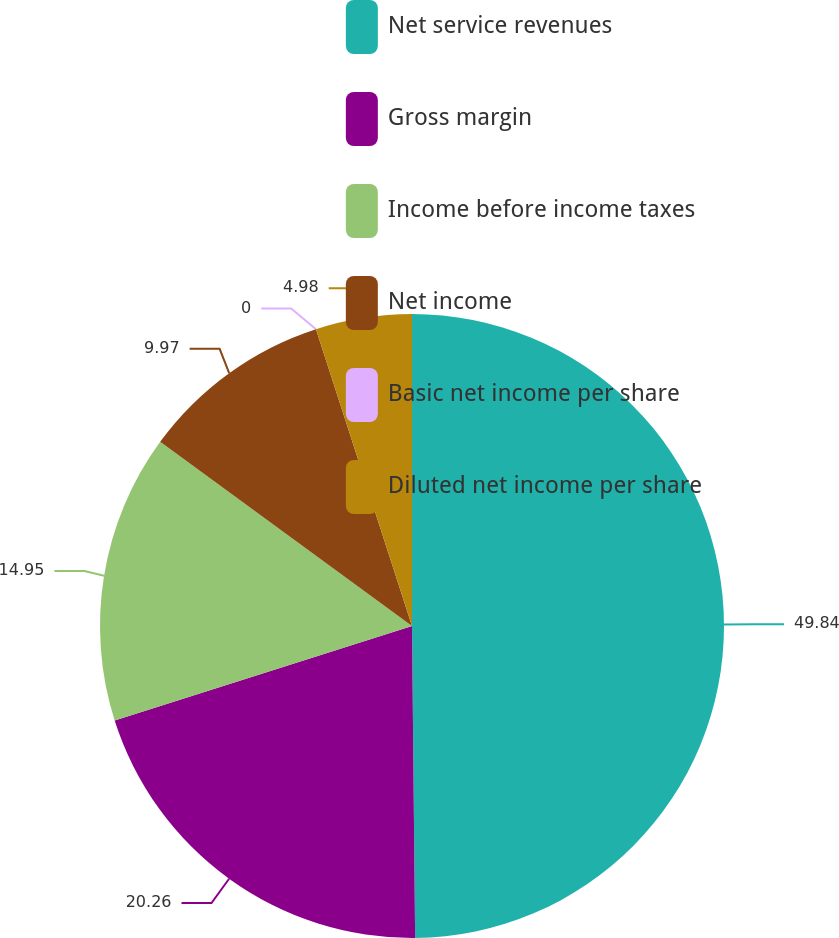Convert chart to OTSL. <chart><loc_0><loc_0><loc_500><loc_500><pie_chart><fcel>Net service revenues<fcel>Gross margin<fcel>Income before income taxes<fcel>Net income<fcel>Basic net income per share<fcel>Diluted net income per share<nl><fcel>49.84%<fcel>20.26%<fcel>14.95%<fcel>9.97%<fcel>0.0%<fcel>4.98%<nl></chart> 